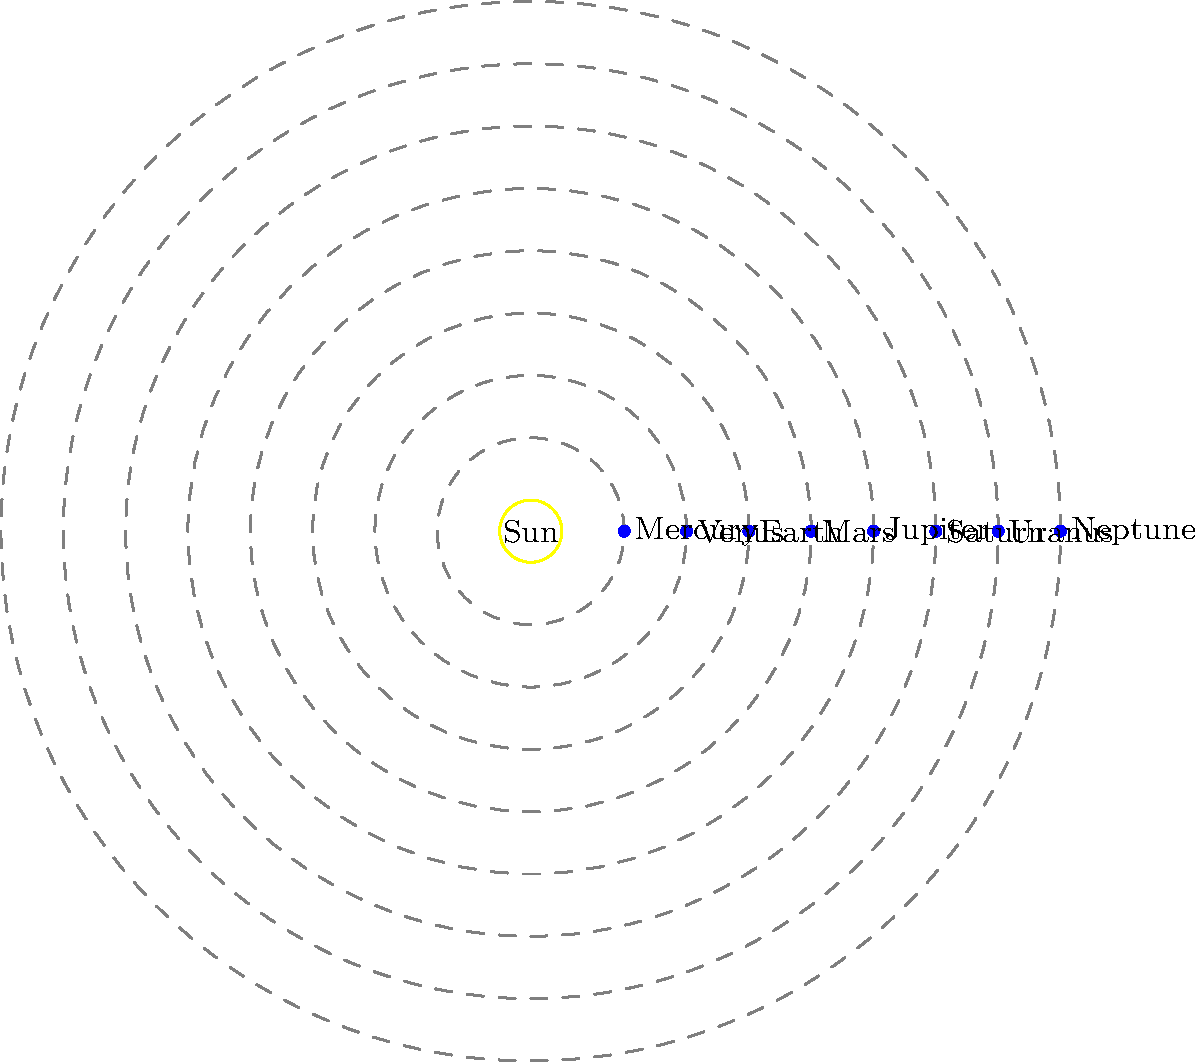In the Solar System model shown, which planet's orbit would be most affected by the gravitational pull of Jupiter, and why is this information important for maintaining accurate e-book resources on planetary movements? To answer this question, we need to consider the following steps:

1. Analyze the diagram: The image shows the orbits of the eight planets in the Solar System, with Jupiter being the fifth planet from the Sun.

2. Consider gravitational effects: The strength of gravitational interaction between two bodies is inversely proportional to the square of the distance between them, as described by Newton's law of universal gravitation:

   $$F = G \frac{m_1 m_2}{r^2}$$

   where $F$ is the gravitational force, $G$ is the gravitational constant, $m_1$ and $m_2$ are the masses of the two bodies, and $r$ is the distance between them.

3. Identify nearby planets: The planets closest to Jupiter are Mars (inward) and Saturn (outward).

4. Compare masses: Jupiter is significantly more massive than Mars (about 3000 times more massive), while Saturn is about one-third of Jupiter's mass.

5. Consider orbital resonances: Mars, being closer to Jupiter and much less massive, is more susceptible to Jupiter's gravitational influence. This can lead to orbital perturbations and resonances.

6. Importance for e-book resources: Accurate information on planetary movements is crucial for:
   a) Understanding long-term orbital stability
   b) Predicting potential close approaches or conjunctions
   c) Planning space missions and observations
   d) Studying the evolution of the Solar System

7. Conclusion: Mars is the planet most affected by Jupiter's gravity due to its proximity and relatively small mass. This information is vital for maintaining up-to-date and accurate e-book resources on planetary dynamics and Solar System structure.
Answer: Mars; crucial for accurate planetary movement data in educational resources. 